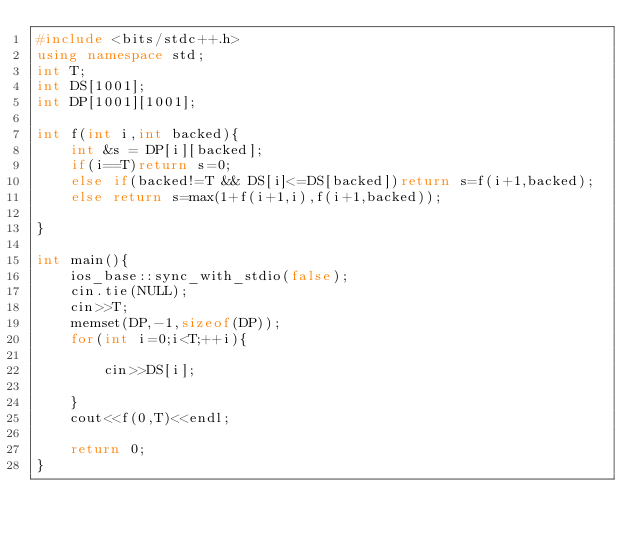<code> <loc_0><loc_0><loc_500><loc_500><_C++_>#include <bits/stdc++.h>
using namespace std;
int T;
int DS[1001];
int DP[1001][1001];

int f(int i,int backed){
    int &s = DP[i][backed];
    if(i==T)return s=0;
    else if(backed!=T && DS[i]<=DS[backed])return s=f(i+1,backed);
    else return s=max(1+f(i+1,i),f(i+1,backed));

}

int main(){
    ios_base::sync_with_stdio(false);
    cin.tie(NULL);
    cin>>T;
    memset(DP,-1,sizeof(DP));
    for(int i=0;i<T;++i){

        cin>>DS[i];

    }
    cout<<f(0,T)<<endl;

    return 0;
}

</code> 